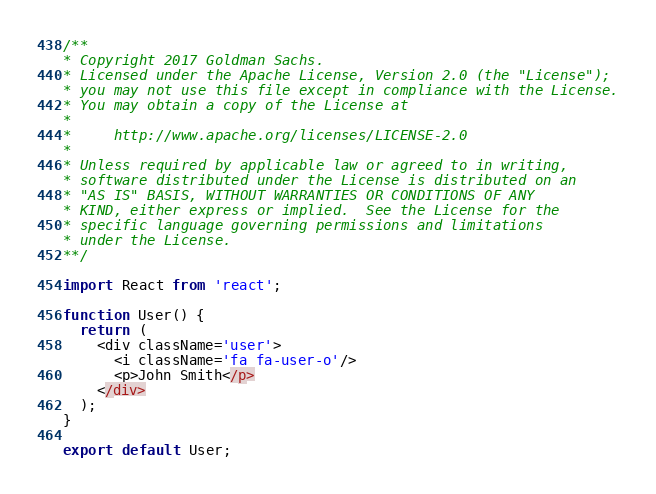<code> <loc_0><loc_0><loc_500><loc_500><_JavaScript_>/**
* Copyright 2017 Goldman Sachs.
* Licensed under the Apache License, Version 2.0 (the "License");
* you may not use this file except in compliance with the License.
* You may obtain a copy of the License at
*
*     http://www.apache.org/licenses/LICENSE-2.0
*
* Unless required by applicable law or agreed to in writing,
* software distributed under the License is distributed on an
* "AS IS" BASIS, WITHOUT WARRANTIES OR CONDITIONS OF ANY
* KIND, either express or implied.  See the License for the
* specific language governing permissions and limitations
* under the License.
**/

import React from 'react';

function User() {
  return (
    <div className='user'>
      <i className='fa fa-user-o'/>
      <p>John Smith</p>
    </div>
  );
}

export default User;
</code> 